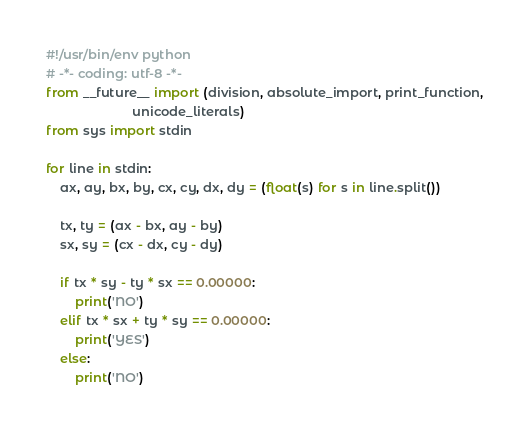Convert code to text. <code><loc_0><loc_0><loc_500><loc_500><_Python_>#!/usr/bin/env python
# -*- coding: utf-8 -*-
from __future__ import (division, absolute_import, print_function,
                        unicode_literals)
from sys import stdin

for line in stdin:
    ax, ay, bx, by, cx, cy, dx, dy = (float(s) for s in line.split())

    tx, ty = (ax - bx, ay - by)
    sx, sy = (cx - dx, cy - dy)

    if tx * sy - ty * sx == 0.00000:
        print('NO')
    elif tx * sx + ty * sy == 0.00000:
        print('YES')
    else:
        print('NO')</code> 